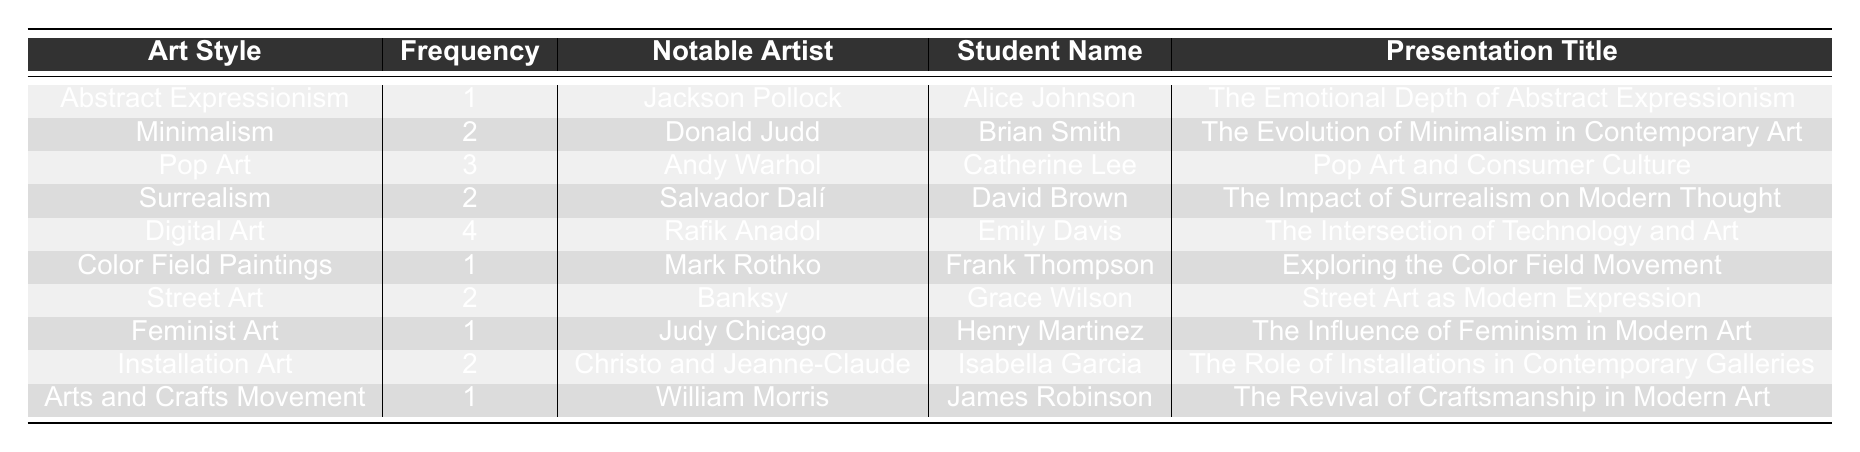What is the most frequently presented art style? The table shows the frequency of each art style. Digital Art has the highest frequency of 4, making it the most frequently presented art style.
Answer: Digital Art Who presented on Street Art? According to the table, Grace Wilson is the student who presented on Street Art.
Answer: Grace Wilson What is the total frequency of Minimalism and Surrealism presentations? To find the total frequency, we add the frequency of Minimalism (2) and Surrealism (2) together: 2 + 2 = 4.
Answer: 4 Is there a presentation by a student on the Arts and Crafts Movement? Yes, the table lists a presentation on Arts and Crafts Movement by James Robinson.
Answer: Yes Which art style has the lowest frequency? Reviewing the table, Abstract Expressionism, Color Field Paintings, Feminist Art, and Arts and Crafts Movement each have a frequency of 1, making them the lowest.
Answer: Abstract Expressionism, Color Field Paintings, Feminist Art, Arts and Crafts Movement How many students presented on art styles related to technology? Looking at the table, only Emily Davis presented on Digital Art, which is related to technology. Therefore, there is just one student.
Answer: 1 Which notable artist is associated with the highest frequency art style? The highest frequency art style is Digital Art, associated with the notable artist Rafik Anadol, as seen in the table.
Answer: Rafik Anadol Are there more presentations on Pop Art or Street Art? The frequency for Pop Art is 3, while for Street Art, it is 2. Since 3 > 2, there are more presentations on Pop Art.
Answer: Pop Art What is the average frequency of the art styles presented? To find the average, we sum all frequencies (1 + 2 + 3 + 2 + 4 + 1 + 2 + 1 + 2 + 1 = 20) and divide by the number of art styles (10): 20 / 10 = 2.
Answer: 2 If we remove the presentations with a frequency of 1, how many presentations remain? The presentations with a frequency of 1 are for Abstract Expressionism, Color Field Paintings, Feminist Art, and Arts and Crafts Movement (4 total). Since there are originally 10 presentations, the remaining presentations are 10 - 4 = 6.
Answer: 6 